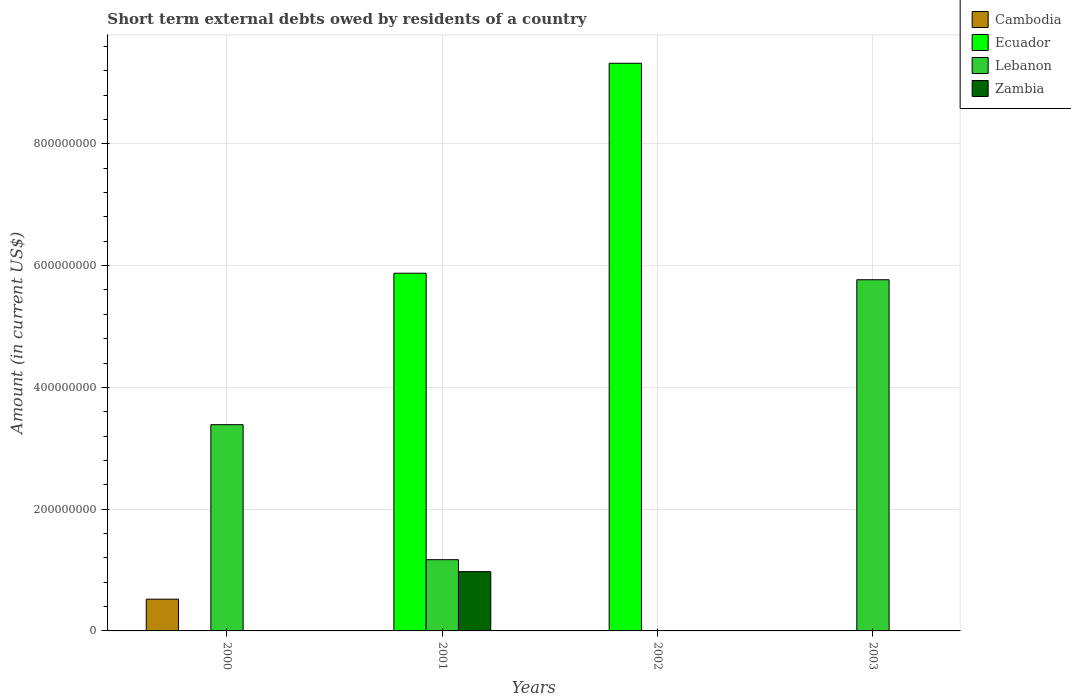Are the number of bars per tick equal to the number of legend labels?
Make the answer very short. No. What is the label of the 2nd group of bars from the left?
Your response must be concise. 2001. In how many cases, is the number of bars for a given year not equal to the number of legend labels?
Provide a short and direct response. 4. Across all years, what is the maximum amount of short-term external debts owed by residents in Zambia?
Provide a short and direct response. 9.73e+07. What is the total amount of short-term external debts owed by residents in Cambodia in the graph?
Offer a terse response. 5.21e+07. What is the difference between the amount of short-term external debts owed by residents in Lebanon in 2000 and the amount of short-term external debts owed by residents in Ecuador in 2003?
Keep it short and to the point. 3.39e+08. What is the average amount of short-term external debts owed by residents in Zambia per year?
Offer a terse response. 2.43e+07. In the year 2001, what is the difference between the amount of short-term external debts owed by residents in Zambia and amount of short-term external debts owed by residents in Lebanon?
Keep it short and to the point. -1.97e+07. What is the difference between the highest and the lowest amount of short-term external debts owed by residents in Cambodia?
Give a very brief answer. 5.21e+07. In how many years, is the amount of short-term external debts owed by residents in Zambia greater than the average amount of short-term external debts owed by residents in Zambia taken over all years?
Your response must be concise. 1. Is the sum of the amount of short-term external debts owed by residents in Ecuador in 2001 and 2002 greater than the maximum amount of short-term external debts owed by residents in Cambodia across all years?
Your answer should be very brief. Yes. Is it the case that in every year, the sum of the amount of short-term external debts owed by residents in Lebanon and amount of short-term external debts owed by residents in Ecuador is greater than the sum of amount of short-term external debts owed by residents in Zambia and amount of short-term external debts owed by residents in Cambodia?
Your response must be concise. No. Is it the case that in every year, the sum of the amount of short-term external debts owed by residents in Cambodia and amount of short-term external debts owed by residents in Lebanon is greater than the amount of short-term external debts owed by residents in Ecuador?
Make the answer very short. No. Are all the bars in the graph horizontal?
Give a very brief answer. No. How many years are there in the graph?
Make the answer very short. 4. What is the difference between two consecutive major ticks on the Y-axis?
Your answer should be very brief. 2.00e+08. Are the values on the major ticks of Y-axis written in scientific E-notation?
Your answer should be very brief. No. Where does the legend appear in the graph?
Offer a very short reply. Top right. How many legend labels are there?
Offer a very short reply. 4. What is the title of the graph?
Your answer should be compact. Short term external debts owed by residents of a country. What is the label or title of the X-axis?
Your answer should be very brief. Years. What is the Amount (in current US$) in Cambodia in 2000?
Your answer should be very brief. 5.21e+07. What is the Amount (in current US$) in Ecuador in 2000?
Offer a terse response. 0. What is the Amount (in current US$) of Lebanon in 2000?
Ensure brevity in your answer.  3.39e+08. What is the Amount (in current US$) in Ecuador in 2001?
Your answer should be very brief. 5.87e+08. What is the Amount (in current US$) of Lebanon in 2001?
Your answer should be very brief. 1.17e+08. What is the Amount (in current US$) in Zambia in 2001?
Your answer should be very brief. 9.73e+07. What is the Amount (in current US$) in Ecuador in 2002?
Offer a very short reply. 9.32e+08. What is the Amount (in current US$) of Cambodia in 2003?
Your answer should be very brief. 0. What is the Amount (in current US$) in Ecuador in 2003?
Your answer should be very brief. 0. What is the Amount (in current US$) of Lebanon in 2003?
Your response must be concise. 5.77e+08. Across all years, what is the maximum Amount (in current US$) of Cambodia?
Your response must be concise. 5.21e+07. Across all years, what is the maximum Amount (in current US$) in Ecuador?
Your answer should be very brief. 9.32e+08. Across all years, what is the maximum Amount (in current US$) of Lebanon?
Provide a succinct answer. 5.77e+08. Across all years, what is the maximum Amount (in current US$) in Zambia?
Give a very brief answer. 9.73e+07. Across all years, what is the minimum Amount (in current US$) in Ecuador?
Offer a very short reply. 0. Across all years, what is the minimum Amount (in current US$) in Lebanon?
Ensure brevity in your answer.  0. What is the total Amount (in current US$) in Cambodia in the graph?
Your answer should be compact. 5.21e+07. What is the total Amount (in current US$) in Ecuador in the graph?
Make the answer very short. 1.52e+09. What is the total Amount (in current US$) of Lebanon in the graph?
Your response must be concise. 1.03e+09. What is the total Amount (in current US$) in Zambia in the graph?
Your answer should be very brief. 9.73e+07. What is the difference between the Amount (in current US$) of Lebanon in 2000 and that in 2001?
Your answer should be very brief. 2.22e+08. What is the difference between the Amount (in current US$) in Lebanon in 2000 and that in 2003?
Keep it short and to the point. -2.38e+08. What is the difference between the Amount (in current US$) in Ecuador in 2001 and that in 2002?
Provide a short and direct response. -3.45e+08. What is the difference between the Amount (in current US$) of Lebanon in 2001 and that in 2003?
Your answer should be very brief. -4.60e+08. What is the difference between the Amount (in current US$) of Cambodia in 2000 and the Amount (in current US$) of Ecuador in 2001?
Offer a terse response. -5.35e+08. What is the difference between the Amount (in current US$) of Cambodia in 2000 and the Amount (in current US$) of Lebanon in 2001?
Keep it short and to the point. -6.49e+07. What is the difference between the Amount (in current US$) of Cambodia in 2000 and the Amount (in current US$) of Zambia in 2001?
Provide a short and direct response. -4.52e+07. What is the difference between the Amount (in current US$) of Lebanon in 2000 and the Amount (in current US$) of Zambia in 2001?
Provide a short and direct response. 2.41e+08. What is the difference between the Amount (in current US$) in Cambodia in 2000 and the Amount (in current US$) in Ecuador in 2002?
Make the answer very short. -8.80e+08. What is the difference between the Amount (in current US$) in Cambodia in 2000 and the Amount (in current US$) in Lebanon in 2003?
Make the answer very short. -5.25e+08. What is the difference between the Amount (in current US$) in Ecuador in 2001 and the Amount (in current US$) in Lebanon in 2003?
Offer a very short reply. 1.07e+07. What is the difference between the Amount (in current US$) of Ecuador in 2002 and the Amount (in current US$) of Lebanon in 2003?
Ensure brevity in your answer.  3.56e+08. What is the average Amount (in current US$) of Cambodia per year?
Your answer should be compact. 1.30e+07. What is the average Amount (in current US$) of Ecuador per year?
Provide a short and direct response. 3.80e+08. What is the average Amount (in current US$) of Lebanon per year?
Give a very brief answer. 2.58e+08. What is the average Amount (in current US$) in Zambia per year?
Your answer should be very brief. 2.43e+07. In the year 2000, what is the difference between the Amount (in current US$) of Cambodia and Amount (in current US$) of Lebanon?
Your response must be concise. -2.87e+08. In the year 2001, what is the difference between the Amount (in current US$) of Ecuador and Amount (in current US$) of Lebanon?
Your answer should be compact. 4.70e+08. In the year 2001, what is the difference between the Amount (in current US$) of Ecuador and Amount (in current US$) of Zambia?
Give a very brief answer. 4.90e+08. In the year 2001, what is the difference between the Amount (in current US$) of Lebanon and Amount (in current US$) of Zambia?
Provide a short and direct response. 1.97e+07. What is the ratio of the Amount (in current US$) in Lebanon in 2000 to that in 2001?
Provide a short and direct response. 2.89. What is the ratio of the Amount (in current US$) in Lebanon in 2000 to that in 2003?
Your response must be concise. 0.59. What is the ratio of the Amount (in current US$) in Ecuador in 2001 to that in 2002?
Your answer should be very brief. 0.63. What is the ratio of the Amount (in current US$) of Lebanon in 2001 to that in 2003?
Offer a very short reply. 0.2. What is the difference between the highest and the second highest Amount (in current US$) in Lebanon?
Offer a terse response. 2.38e+08. What is the difference between the highest and the lowest Amount (in current US$) in Cambodia?
Give a very brief answer. 5.21e+07. What is the difference between the highest and the lowest Amount (in current US$) of Ecuador?
Your response must be concise. 9.32e+08. What is the difference between the highest and the lowest Amount (in current US$) in Lebanon?
Provide a succinct answer. 5.77e+08. What is the difference between the highest and the lowest Amount (in current US$) of Zambia?
Give a very brief answer. 9.73e+07. 